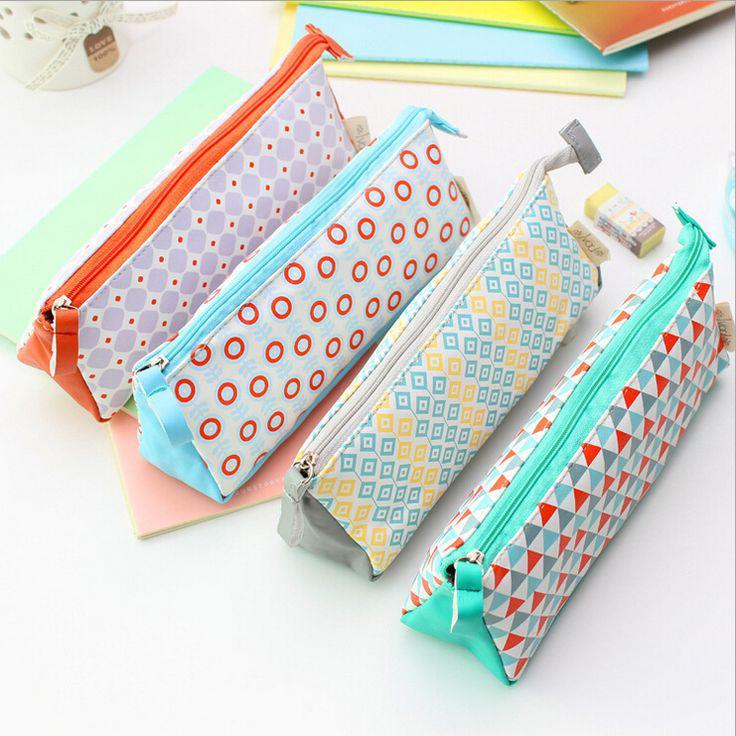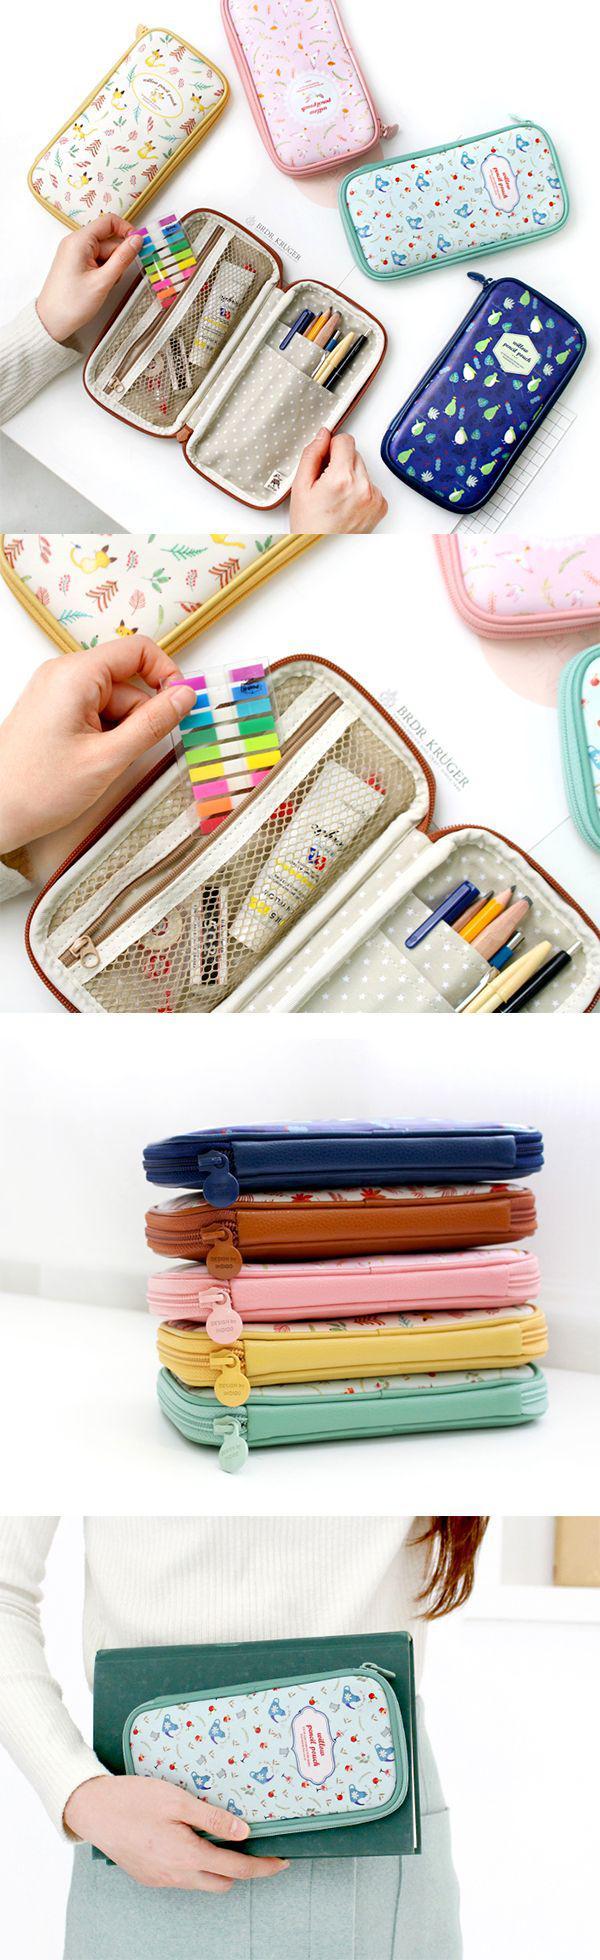The first image is the image on the left, the second image is the image on the right. Given the left and right images, does the statement "The left image shows one case with at least some contents visible." hold true? Answer yes or no. No. 